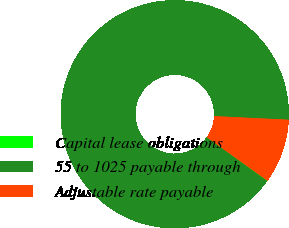Convert chart to OTSL. <chart><loc_0><loc_0><loc_500><loc_500><pie_chart><fcel>Capital lease obligations<fcel>55 to 1025 payable through<fcel>Adjustable rate payable<nl><fcel>0.06%<fcel>90.8%<fcel>9.14%<nl></chart> 